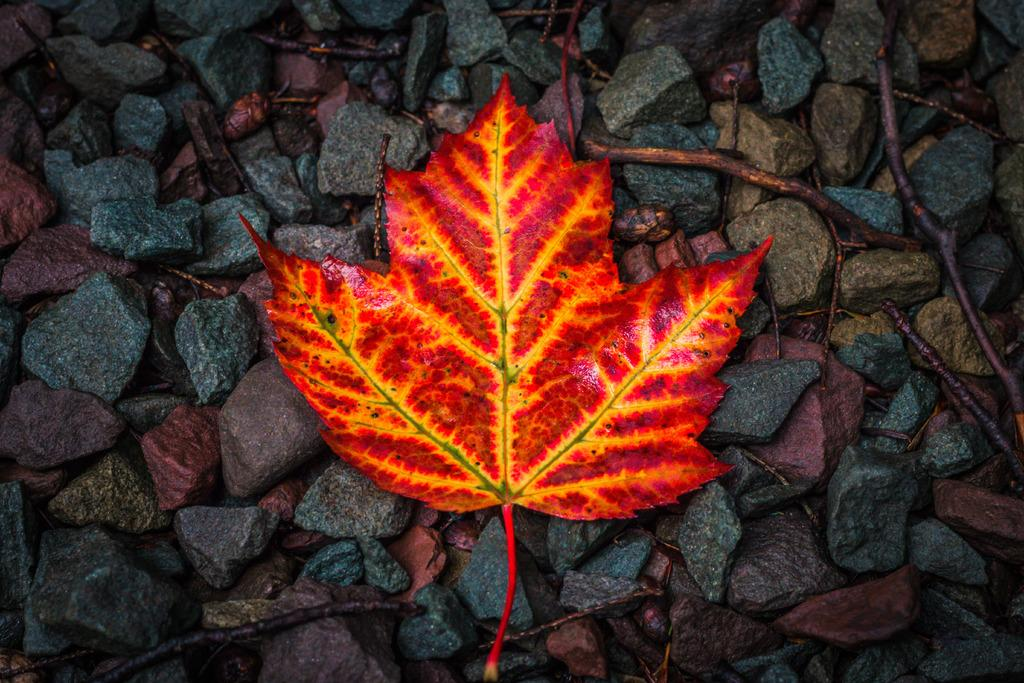What is the main subject in the center of the image? There is a leaf in the center of the image. What can be seen in the background of the image? There are stones and sticks in the background of the image. What type of popcorn activity is happening in the image? There is no popcorn or activity involving popcorn present in the image. 